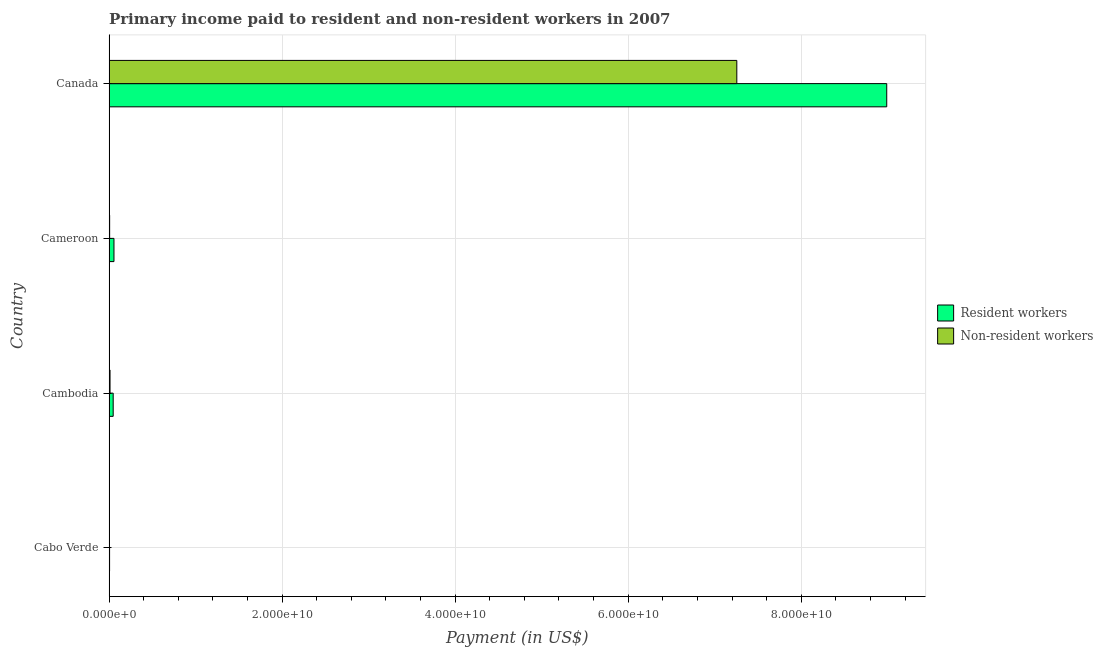Are the number of bars per tick equal to the number of legend labels?
Provide a succinct answer. Yes. Are the number of bars on each tick of the Y-axis equal?
Your answer should be very brief. Yes. How many bars are there on the 4th tick from the top?
Your response must be concise. 2. How many bars are there on the 3rd tick from the bottom?
Ensure brevity in your answer.  2. What is the label of the 4th group of bars from the top?
Your response must be concise. Cabo Verde. In how many cases, is the number of bars for a given country not equal to the number of legend labels?
Make the answer very short. 0. What is the payment made to non-resident workers in Cambodia?
Provide a short and direct response. 1.12e+08. Across all countries, what is the maximum payment made to resident workers?
Provide a short and direct response. 8.99e+1. Across all countries, what is the minimum payment made to resident workers?
Your response must be concise. 5.89e+07. In which country was the payment made to resident workers minimum?
Your answer should be very brief. Cabo Verde. What is the total payment made to resident workers in the graph?
Your answer should be very brief. 9.10e+1. What is the difference between the payment made to resident workers in Cabo Verde and that in Cambodia?
Your response must be concise. -4.17e+08. What is the difference between the payment made to non-resident workers in Canada and the payment made to resident workers in Cabo Verde?
Make the answer very short. 7.25e+1. What is the average payment made to non-resident workers per country?
Ensure brevity in your answer.  1.82e+1. What is the difference between the payment made to non-resident workers and payment made to resident workers in Cameroon?
Make the answer very short. -4.99e+08. In how many countries, is the payment made to resident workers greater than 68000000000 US$?
Your answer should be very brief. 1. Is the payment made to non-resident workers in Cameroon less than that in Canada?
Offer a very short reply. Yes. What is the difference between the highest and the second highest payment made to resident workers?
Your answer should be compact. 8.93e+1. What is the difference between the highest and the lowest payment made to non-resident workers?
Ensure brevity in your answer.  7.25e+1. In how many countries, is the payment made to non-resident workers greater than the average payment made to non-resident workers taken over all countries?
Offer a very short reply. 1. Is the sum of the payment made to non-resident workers in Cabo Verde and Canada greater than the maximum payment made to resident workers across all countries?
Offer a terse response. No. What does the 2nd bar from the top in Cameroon represents?
Offer a terse response. Resident workers. What does the 1st bar from the bottom in Canada represents?
Your answer should be compact. Resident workers. How many bars are there?
Offer a very short reply. 8. What is the difference between two consecutive major ticks on the X-axis?
Offer a terse response. 2.00e+1. Does the graph contain any zero values?
Offer a very short reply. No. Does the graph contain grids?
Your answer should be very brief. Yes. How are the legend labels stacked?
Your answer should be very brief. Vertical. What is the title of the graph?
Ensure brevity in your answer.  Primary income paid to resident and non-resident workers in 2007. Does "Number of arrivals" appear as one of the legend labels in the graph?
Offer a very short reply. No. What is the label or title of the X-axis?
Give a very brief answer. Payment (in US$). What is the label or title of the Y-axis?
Offer a terse response. Country. What is the Payment (in US$) of Resident workers in Cabo Verde?
Offer a very short reply. 5.89e+07. What is the Payment (in US$) in Non-resident workers in Cabo Verde?
Ensure brevity in your answer.  2.67e+07. What is the Payment (in US$) of Resident workers in Cambodia?
Your answer should be very brief. 4.76e+08. What is the Payment (in US$) of Non-resident workers in Cambodia?
Ensure brevity in your answer.  1.12e+08. What is the Payment (in US$) in Resident workers in Cameroon?
Give a very brief answer. 5.66e+08. What is the Payment (in US$) in Non-resident workers in Cameroon?
Offer a very short reply. 6.69e+07. What is the Payment (in US$) in Resident workers in Canada?
Your answer should be compact. 8.99e+1. What is the Payment (in US$) in Non-resident workers in Canada?
Make the answer very short. 7.26e+1. Across all countries, what is the maximum Payment (in US$) in Resident workers?
Provide a succinct answer. 8.99e+1. Across all countries, what is the maximum Payment (in US$) in Non-resident workers?
Give a very brief answer. 7.26e+1. Across all countries, what is the minimum Payment (in US$) in Resident workers?
Make the answer very short. 5.89e+07. Across all countries, what is the minimum Payment (in US$) in Non-resident workers?
Ensure brevity in your answer.  2.67e+07. What is the total Payment (in US$) of Resident workers in the graph?
Provide a short and direct response. 9.10e+1. What is the total Payment (in US$) of Non-resident workers in the graph?
Ensure brevity in your answer.  7.28e+1. What is the difference between the Payment (in US$) in Resident workers in Cabo Verde and that in Cambodia?
Your answer should be compact. -4.17e+08. What is the difference between the Payment (in US$) in Non-resident workers in Cabo Verde and that in Cambodia?
Your answer should be compact. -8.55e+07. What is the difference between the Payment (in US$) in Resident workers in Cabo Verde and that in Cameroon?
Your answer should be compact. -5.07e+08. What is the difference between the Payment (in US$) of Non-resident workers in Cabo Verde and that in Cameroon?
Your response must be concise. -4.02e+07. What is the difference between the Payment (in US$) of Resident workers in Cabo Verde and that in Canada?
Offer a very short reply. -8.98e+1. What is the difference between the Payment (in US$) of Non-resident workers in Cabo Verde and that in Canada?
Your answer should be compact. -7.25e+1. What is the difference between the Payment (in US$) of Resident workers in Cambodia and that in Cameroon?
Your answer should be compact. -8.99e+07. What is the difference between the Payment (in US$) in Non-resident workers in Cambodia and that in Cameroon?
Ensure brevity in your answer.  4.54e+07. What is the difference between the Payment (in US$) of Resident workers in Cambodia and that in Canada?
Make the answer very short. -8.94e+1. What is the difference between the Payment (in US$) of Non-resident workers in Cambodia and that in Canada?
Make the answer very short. -7.24e+1. What is the difference between the Payment (in US$) of Resident workers in Cameroon and that in Canada?
Keep it short and to the point. -8.93e+1. What is the difference between the Payment (in US$) in Non-resident workers in Cameroon and that in Canada?
Your answer should be very brief. -7.25e+1. What is the difference between the Payment (in US$) in Resident workers in Cabo Verde and the Payment (in US$) in Non-resident workers in Cambodia?
Provide a short and direct response. -5.33e+07. What is the difference between the Payment (in US$) of Resident workers in Cabo Verde and the Payment (in US$) of Non-resident workers in Cameroon?
Offer a terse response. -7.98e+06. What is the difference between the Payment (in US$) of Resident workers in Cabo Verde and the Payment (in US$) of Non-resident workers in Canada?
Your answer should be compact. -7.25e+1. What is the difference between the Payment (in US$) in Resident workers in Cambodia and the Payment (in US$) in Non-resident workers in Cameroon?
Offer a very short reply. 4.09e+08. What is the difference between the Payment (in US$) of Resident workers in Cambodia and the Payment (in US$) of Non-resident workers in Canada?
Give a very brief answer. -7.21e+1. What is the difference between the Payment (in US$) of Resident workers in Cameroon and the Payment (in US$) of Non-resident workers in Canada?
Offer a very short reply. -7.20e+1. What is the average Payment (in US$) in Resident workers per country?
Make the answer very short. 2.27e+1. What is the average Payment (in US$) of Non-resident workers per country?
Your answer should be compact. 1.82e+1. What is the difference between the Payment (in US$) in Resident workers and Payment (in US$) in Non-resident workers in Cabo Verde?
Your answer should be very brief. 3.22e+07. What is the difference between the Payment (in US$) in Resident workers and Payment (in US$) in Non-resident workers in Cambodia?
Make the answer very short. 3.64e+08. What is the difference between the Payment (in US$) of Resident workers and Payment (in US$) of Non-resident workers in Cameroon?
Provide a succinct answer. 4.99e+08. What is the difference between the Payment (in US$) of Resident workers and Payment (in US$) of Non-resident workers in Canada?
Keep it short and to the point. 1.73e+1. What is the ratio of the Payment (in US$) of Resident workers in Cabo Verde to that in Cambodia?
Your answer should be compact. 0.12. What is the ratio of the Payment (in US$) in Non-resident workers in Cabo Verde to that in Cambodia?
Offer a terse response. 0.24. What is the ratio of the Payment (in US$) of Resident workers in Cabo Verde to that in Cameroon?
Offer a very short reply. 0.1. What is the ratio of the Payment (in US$) in Non-resident workers in Cabo Verde to that in Cameroon?
Provide a succinct answer. 0.4. What is the ratio of the Payment (in US$) of Resident workers in Cabo Verde to that in Canada?
Provide a succinct answer. 0. What is the ratio of the Payment (in US$) in Non-resident workers in Cabo Verde to that in Canada?
Keep it short and to the point. 0. What is the ratio of the Payment (in US$) of Resident workers in Cambodia to that in Cameroon?
Provide a short and direct response. 0.84. What is the ratio of the Payment (in US$) in Non-resident workers in Cambodia to that in Cameroon?
Make the answer very short. 1.68. What is the ratio of the Payment (in US$) of Resident workers in Cambodia to that in Canada?
Keep it short and to the point. 0.01. What is the ratio of the Payment (in US$) in Non-resident workers in Cambodia to that in Canada?
Your answer should be very brief. 0. What is the ratio of the Payment (in US$) of Resident workers in Cameroon to that in Canada?
Your answer should be very brief. 0.01. What is the ratio of the Payment (in US$) of Non-resident workers in Cameroon to that in Canada?
Your answer should be compact. 0. What is the difference between the highest and the second highest Payment (in US$) of Resident workers?
Provide a succinct answer. 8.93e+1. What is the difference between the highest and the second highest Payment (in US$) of Non-resident workers?
Provide a short and direct response. 7.24e+1. What is the difference between the highest and the lowest Payment (in US$) in Resident workers?
Make the answer very short. 8.98e+1. What is the difference between the highest and the lowest Payment (in US$) of Non-resident workers?
Offer a very short reply. 7.25e+1. 